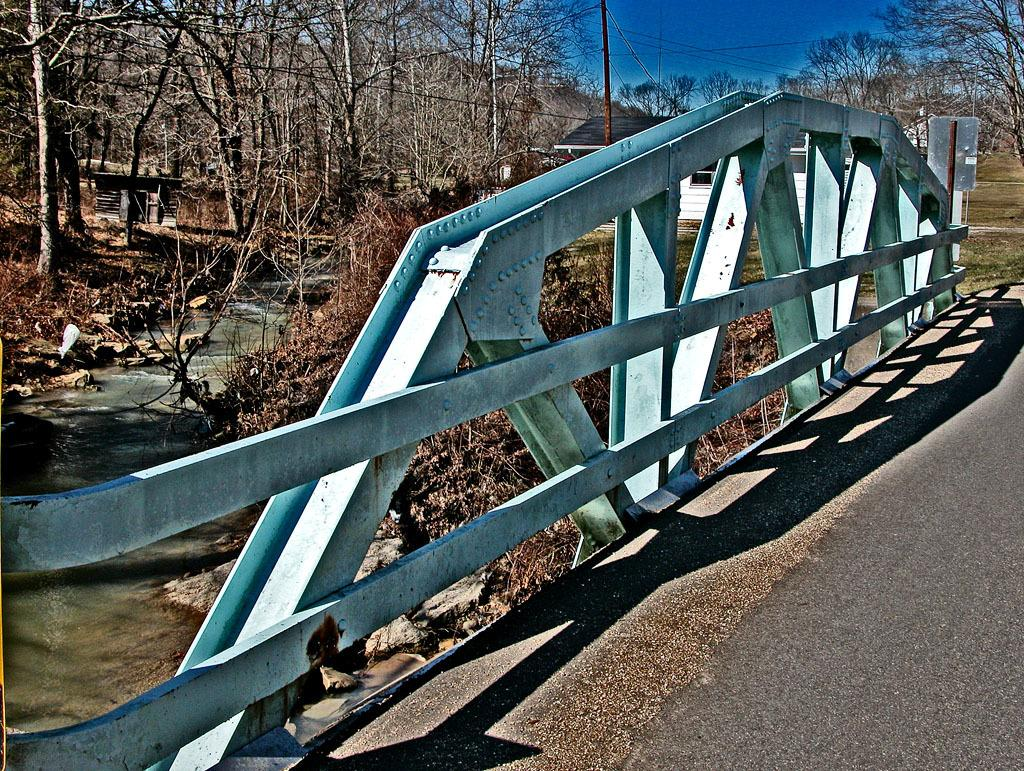What is the main feature of the image? There is a road in the image. Are there any other structures or objects visible? Yes, there is a fence and a door in the image. What can be seen in the background of the image? In the background, there is a river, trees, a pole with wires, and the sky. What type of zephyr can be seen blowing through the trees in the image? There is no mention of a zephyr in the image, and it is not visible. 